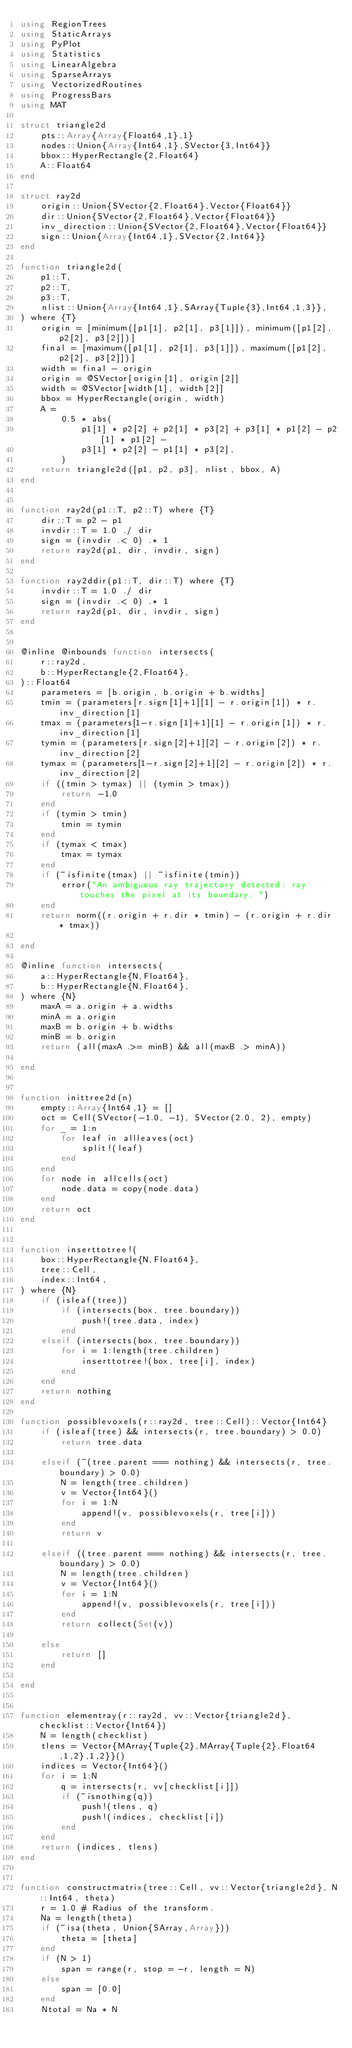Convert code to text. <code><loc_0><loc_0><loc_500><loc_500><_Julia_>using RegionTrees
using StaticArrays
using PyPlot
using Statistics
using LinearAlgebra
using SparseArrays
using VectorizedRoutines
using ProgressBars
using MAT

struct triangle2d
    pts::Array{Array{Float64,1},1}
    nodes::Union{Array{Int64,1},SVector{3,Int64}}
    bbox::HyperRectangle{2,Float64}
    A::Float64
end

struct ray2d
    origin::Union{SVector{2,Float64},Vector{Float64}}
    dir::Union{SVector{2,Float64},Vector{Float64}}
    inv_direction::Union{SVector{2,Float64},Vector{Float64}}
    sign::Union{Array{Int64,1},SVector{2,Int64}}
end

function triangle2d(
    p1::T,
    p2::T,
    p3::T,
    nlist::Union{Array{Int64,1},SArray{Tuple{3},Int64,1,3}},
) where {T}
    origin = [minimum([p1[1], p2[1], p3[1]]), minimum([p1[2], p2[2], p3[2]])]
    final = [maximum([p1[1], p2[1], p3[1]]), maximum([p1[2], p2[2], p3[2]])]
    width = final - origin
    origin = @SVector[origin[1], origin[2]]
    width = @SVector[width[1], width[2]]
    bbox = HyperRectangle(origin, width)
    A =
        0.5 * abs(
            p1[1] * p2[2] + p2[1] * p3[2] + p3[1] * p1[2] - p2[1] * p1[2] -
            p3[1] * p2[2] - p1[1] * p3[2],
        )
    return triangle2d([p1, p2, p3], nlist, bbox, A)
end


function ray2d(p1::T, p2::T) where {T}
    dir::T = p2 - p1
    invdir::T = 1.0 ./ dir
    sign = (invdir .< 0) .* 1
    return ray2d(p1, dir, invdir, sign)
end

function ray2ddir(p1::T, dir::T) where {T}
    invdir::T = 1.0 ./ dir
    sign = (invdir .< 0) .* 1
    return ray2d(p1, dir, invdir, sign)
end


@inline @inbounds function intersects(
    r::ray2d,
    b::HyperRectangle{2,Float64},
)::Float64
    parameters = [b.origin, b.origin + b.widths]
    tmin = (parameters[r.sign[1]+1][1] - r.origin[1]) * r.inv_direction[1]
    tmax = (parameters[1-r.sign[1]+1][1] - r.origin[1]) * r.inv_direction[1]
    tymin = (parameters[r.sign[2]+1][2] - r.origin[2]) * r.inv_direction[2]
    tymax = (parameters[1-r.sign[2]+1][2] - r.origin[2]) * r.inv_direction[2]
    if ((tmin > tymax) || (tymin > tmax))
        return -1.0
    end
    if (tymin > tmin)
        tmin = tymin
    end
    if (tymax < tmax)
        tmax = tymax
    end
    if (~isfinite(tmax) || ~isfinite(tmin))
        error("An ambiguous ray trajectory detected: ray touches the pixel at its boundary. ")
    end
    return norm((r.origin + r.dir * tmin) - (r.origin + r.dir * tmax))

end

@inline function intersects(
    a::HyperRectangle{N,Float64},
    b::HyperRectangle{N,Float64},
) where {N}
    maxA = a.origin + a.widths
    minA = a.origin
    maxB = b.origin + b.widths
    minB = b.origin
    return (all(maxA .>= minB) && all(maxB .> minA))

end


function inittree2d(n)
    empty::Array{Int64,1} = []
    oct = Cell(SVector(-1.0, -1), SVector(2.0, 2), empty)
    for _ = 1:n
        for leaf in allleaves(oct)
            split!(leaf)
        end
    end
    for node in allcells(oct)
        node.data = copy(node.data)
    end
    return oct
end


function inserttotree!(
    box::HyperRectangle{N,Float64},
    tree::Cell,
    index::Int64,
) where {N}
    if (isleaf(tree))
        if (intersects(box, tree.boundary))
            push!(tree.data, index)
        end
    elseif (intersects(box, tree.boundary))
        for i = 1:length(tree.children)
            inserttotree!(box, tree[i], index)
        end
    end
    return nothing
end

function possiblevoxels(r::ray2d, tree::Cell)::Vector{Int64}
    if (isleaf(tree) && intersects(r, tree.boundary) > 0.0)
        return tree.data

    elseif (~(tree.parent === nothing) && intersects(r, tree.boundary) > 0.0)
        N = length(tree.children)
        v = Vector{Int64}()
        for i = 1:N
            append!(v, possiblevoxels(r, tree[i]))
        end
        return v

    elseif ((tree.parent === nothing) && intersects(r, tree.boundary) > 0.0)
        N = length(tree.children)
        v = Vector{Int64}()
        for i = 1:N
            append!(v, possiblevoxels(r, tree[i]))
        end
        return collect(Set(v))

    else
        return []
    end

end


function elementray(r::ray2d, vv::Vector{triangle2d}, checklist::Vector{Int64})
    N = length(checklist)
    tlens = Vector{MArray{Tuple{2},MArray{Tuple{2},Float64,1,2},1,2}}()
    indices = Vector{Int64}()
    for i = 1:N
        q = intersects(r, vv[checklist[i]])
        if (~isnothing(q))
            push!(tlens, q)
            push!(indices, checklist[i])
        end
    end
    return (indices, tlens)
end


function constructmatrix(tree::Cell, vv::Vector{triangle2d}, N::Int64, theta)
    r = 1.0 # Radius of the transform.
    Na = length(theta)
    if (~isa(theta, Union{SArray,Array}))
        theta = [theta]
    end
    if (N > 1)
        span = range(r, stop = -r, length = N)
    else
        span = [0.0]
    end
    Ntotal = Na * N</code> 